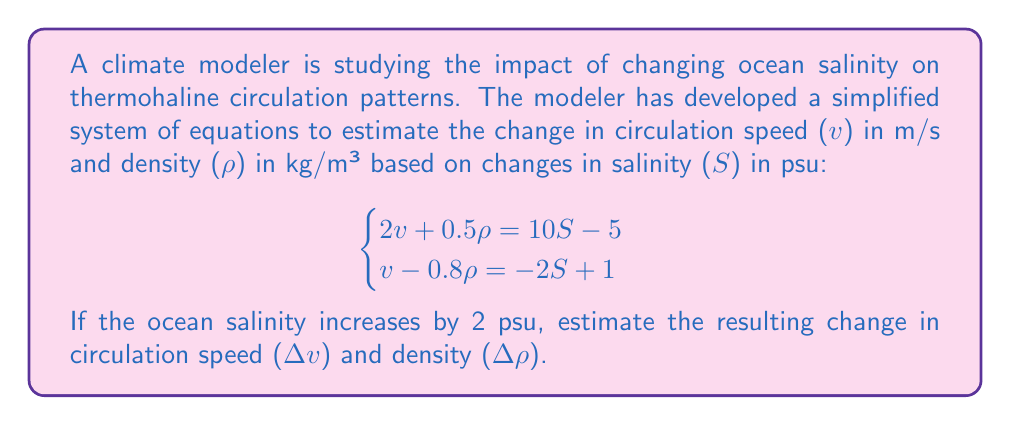Show me your answer to this math problem. To solve this problem, we'll follow these steps:

1) First, we need to solve the system of equations for v and ρ in terms of S.

2) We can use substitution method. From the second equation:
   $v = -2S + 1 + 0.8\rho$

3) Substitute this into the first equation:
   $2(-2S + 1 + 0.8\rho) + 0.5\rho = 10S - 5$
   $-4S + 2 + 1.6\rho + 0.5\rho = 10S - 5$
   $2.1\rho = 14S - 7$
   $\rho = \frac{14S - 7}{2.1} = \frac{20S - 10}{3}$

4) Now substitute this back into the equation for v:
   $v = -2S + 1 + 0.8(\frac{20S - 10}{3})$
   $v = -2S + 1 + \frac{16S - 8}{3}$
   $v = -2S + 1 + \frac{16S - 8}{3}$
   $v = \frac{-6S + 3 + 16S - 8}{3} = \frac{10S - 5}{3}$

5) Now we have equations for v and ρ in terms of S:
   $v = \frac{10S - 5}{3}$
   $\rho = \frac{20S - 10}{3}$

6) To find the change when S increases by 2, we calculate:
   $\Delta v = v(S+2) - v(S) = \frac{10(S+2) - 5}{3} - \frac{10S - 5}{3} = \frac{20}{3} = \frac{20}{3}$
   $\Delta \rho = \rho(S+2) - \rho(S) = \frac{20(S+2) - 10}{3} - \frac{20S - 10}{3} = \frac{40}{3}$

Therefore, when salinity increases by 2 psu, the circulation speed increases by $\frac{20}{3}$ m/s and the density increases by $\frac{40}{3}$ kg/m³.
Answer: Change in circulation speed (Δv) = $\frac{20}{3}$ m/s
Change in density (Δρ) = $\frac{40}{3}$ kg/m³ 